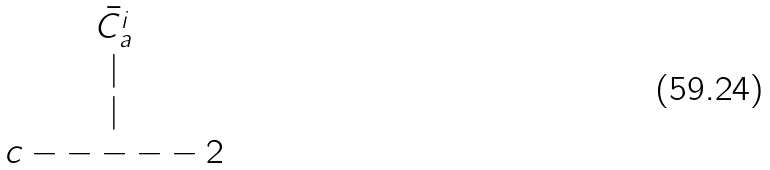Convert formula to latex. <formula><loc_0><loc_0><loc_500><loc_500>\begin{matrix} \bar { C _ { a } ^ { i } } \\ | \\ | \\ c - - - - - 2 \end{matrix}</formula> 